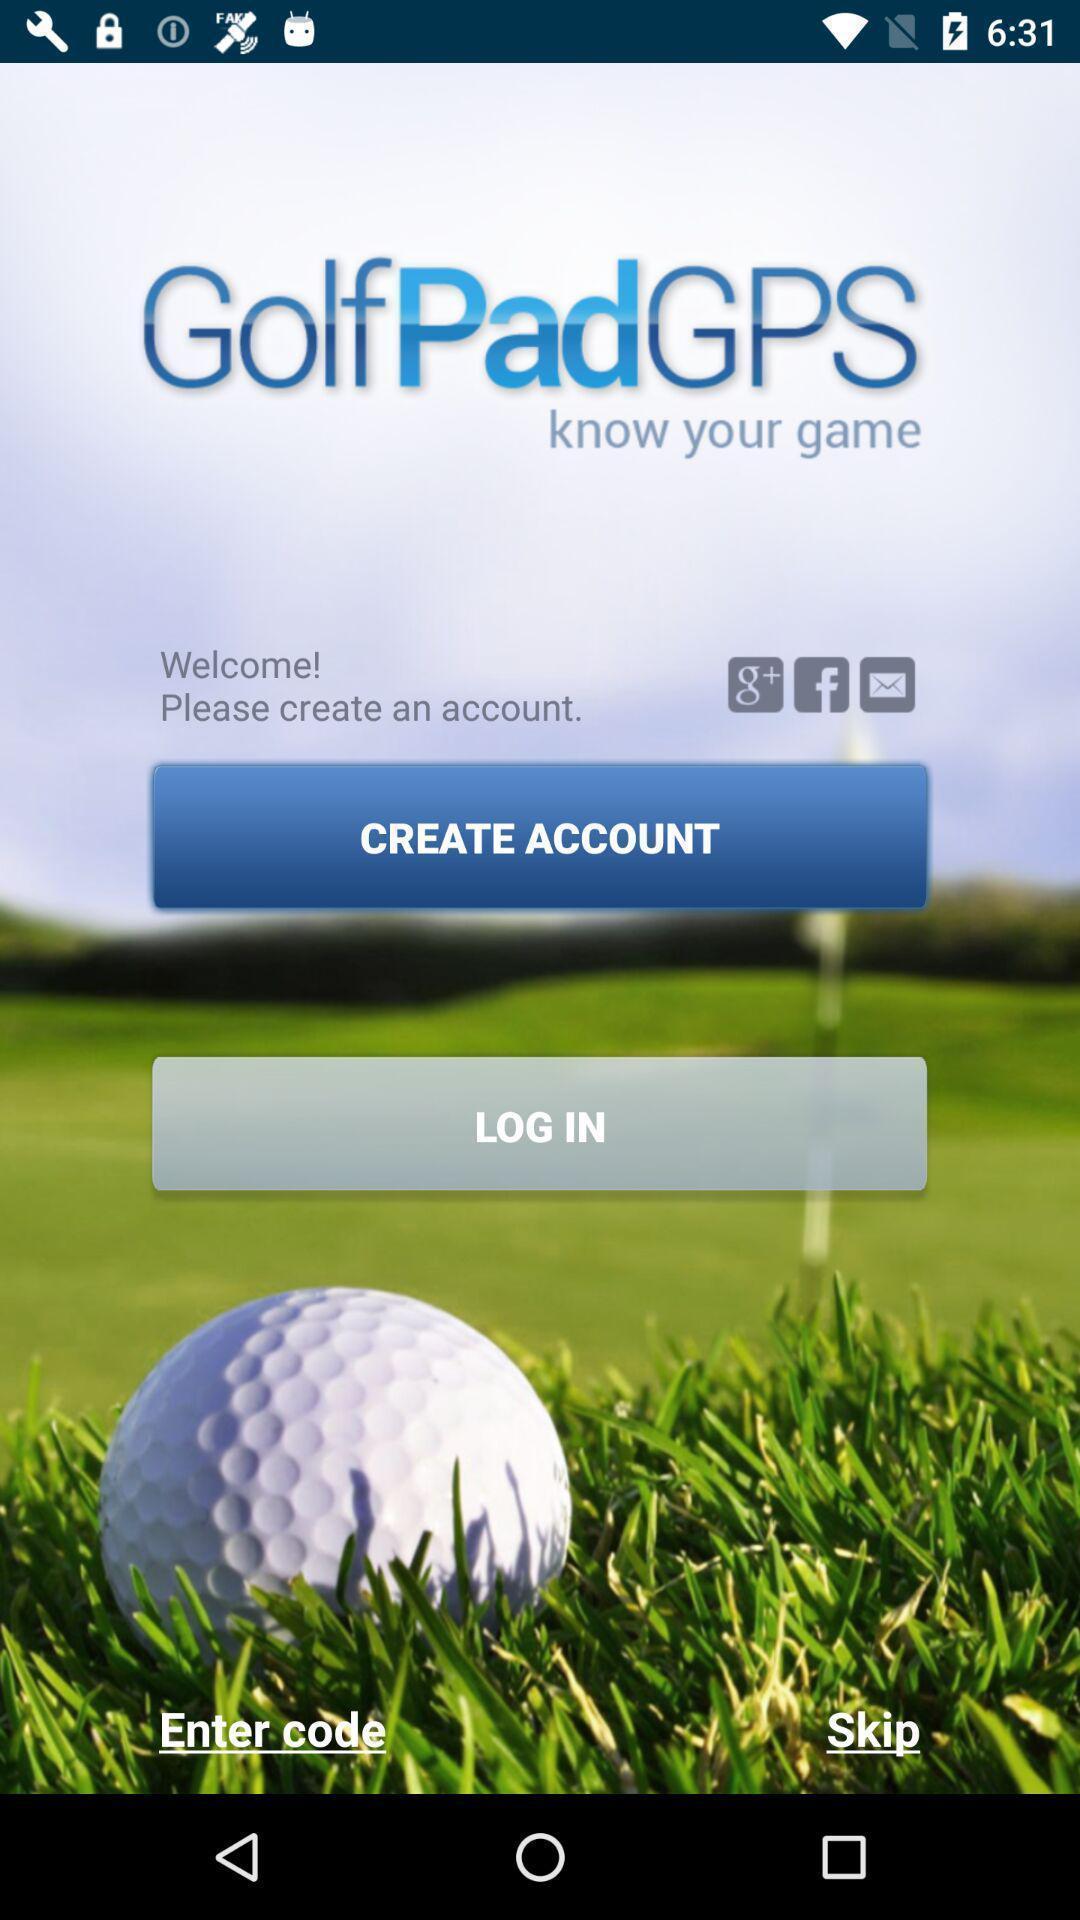Provide a textual representation of this image. Login page for a golf game tracking app. 